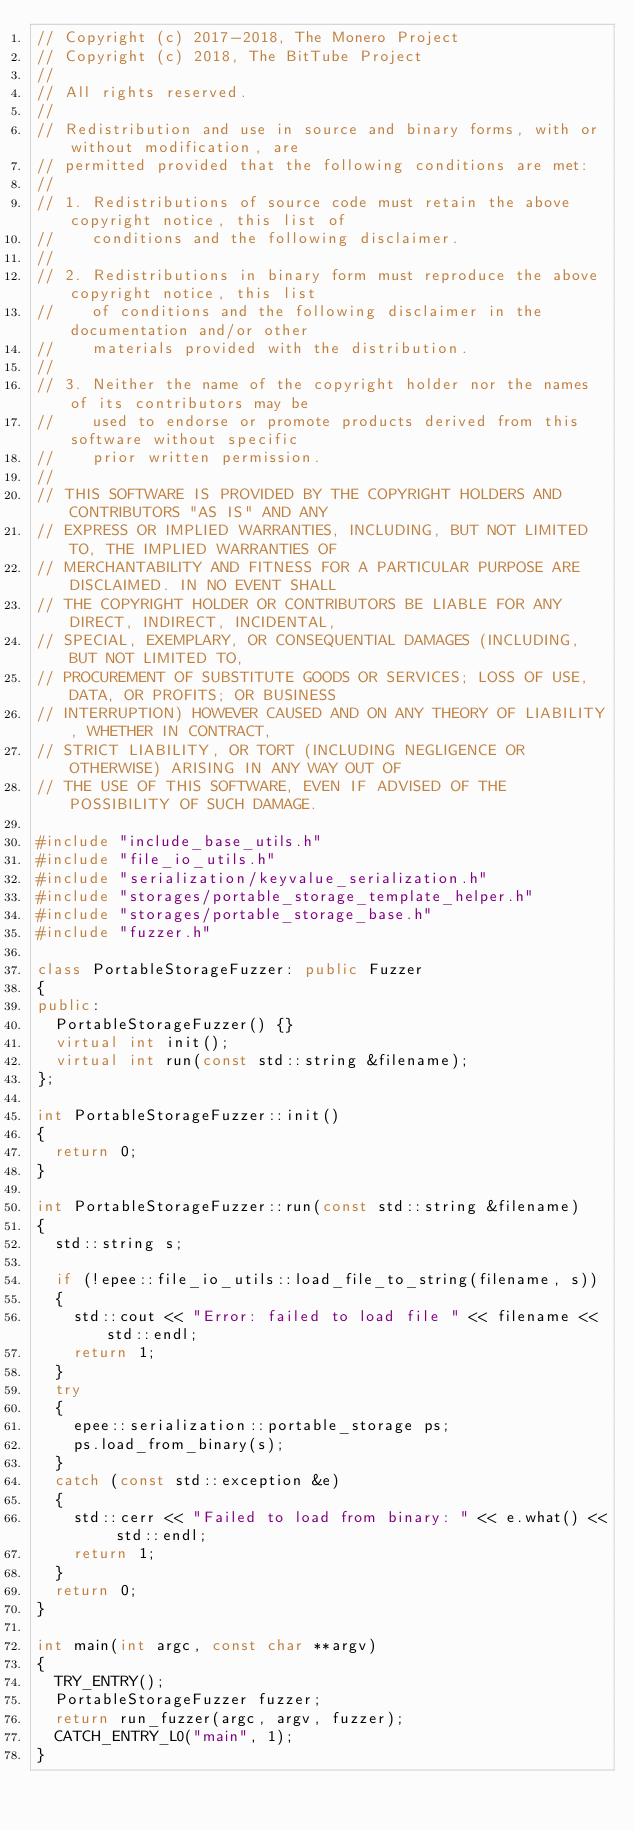Convert code to text. <code><loc_0><loc_0><loc_500><loc_500><_C++_>// Copyright (c) 2017-2018, The Monero Project
// Copyright (c) 2018, The BitTube Project
// 
// All rights reserved.
// 
// Redistribution and use in source and binary forms, with or without modification, are
// permitted provided that the following conditions are met:
// 
// 1. Redistributions of source code must retain the above copyright notice, this list of
//    conditions and the following disclaimer.
// 
// 2. Redistributions in binary form must reproduce the above copyright notice, this list
//    of conditions and the following disclaimer in the documentation and/or other
//    materials provided with the distribution.
// 
// 3. Neither the name of the copyright holder nor the names of its contributors may be
//    used to endorse or promote products derived from this software without specific
//    prior written permission.
// 
// THIS SOFTWARE IS PROVIDED BY THE COPYRIGHT HOLDERS AND CONTRIBUTORS "AS IS" AND ANY
// EXPRESS OR IMPLIED WARRANTIES, INCLUDING, BUT NOT LIMITED TO, THE IMPLIED WARRANTIES OF
// MERCHANTABILITY AND FITNESS FOR A PARTICULAR PURPOSE ARE DISCLAIMED. IN NO EVENT SHALL
// THE COPYRIGHT HOLDER OR CONTRIBUTORS BE LIABLE FOR ANY DIRECT, INDIRECT, INCIDENTAL,
// SPECIAL, EXEMPLARY, OR CONSEQUENTIAL DAMAGES (INCLUDING, BUT NOT LIMITED TO,
// PROCUREMENT OF SUBSTITUTE GOODS OR SERVICES; LOSS OF USE, DATA, OR PROFITS; OR BUSINESS
// INTERRUPTION) HOWEVER CAUSED AND ON ANY THEORY OF LIABILITY, WHETHER IN CONTRACT,
// STRICT LIABILITY, OR TORT (INCLUDING NEGLIGENCE OR OTHERWISE) ARISING IN ANY WAY OUT OF
// THE USE OF THIS SOFTWARE, EVEN IF ADVISED OF THE POSSIBILITY OF SUCH DAMAGE.

#include "include_base_utils.h"
#include "file_io_utils.h"
#include "serialization/keyvalue_serialization.h"
#include "storages/portable_storage_template_helper.h"
#include "storages/portable_storage_base.h"
#include "fuzzer.h"

class PortableStorageFuzzer: public Fuzzer
{
public:
  PortableStorageFuzzer() {}
  virtual int init();
  virtual int run(const std::string &filename);
};

int PortableStorageFuzzer::init()
{
  return 0;
}

int PortableStorageFuzzer::run(const std::string &filename)
{
  std::string s;

  if (!epee::file_io_utils::load_file_to_string(filename, s))
  {
    std::cout << "Error: failed to load file " << filename << std::endl;
    return 1;
  }
  try
  {
    epee::serialization::portable_storage ps;
    ps.load_from_binary(s);
  }
  catch (const std::exception &e)
  {
    std::cerr << "Failed to load from binary: " << e.what() << std::endl;
    return 1;
  }
  return 0;
}

int main(int argc, const char **argv)
{
  TRY_ENTRY();
  PortableStorageFuzzer fuzzer;
  return run_fuzzer(argc, argv, fuzzer);
  CATCH_ENTRY_L0("main", 1);
}

</code> 